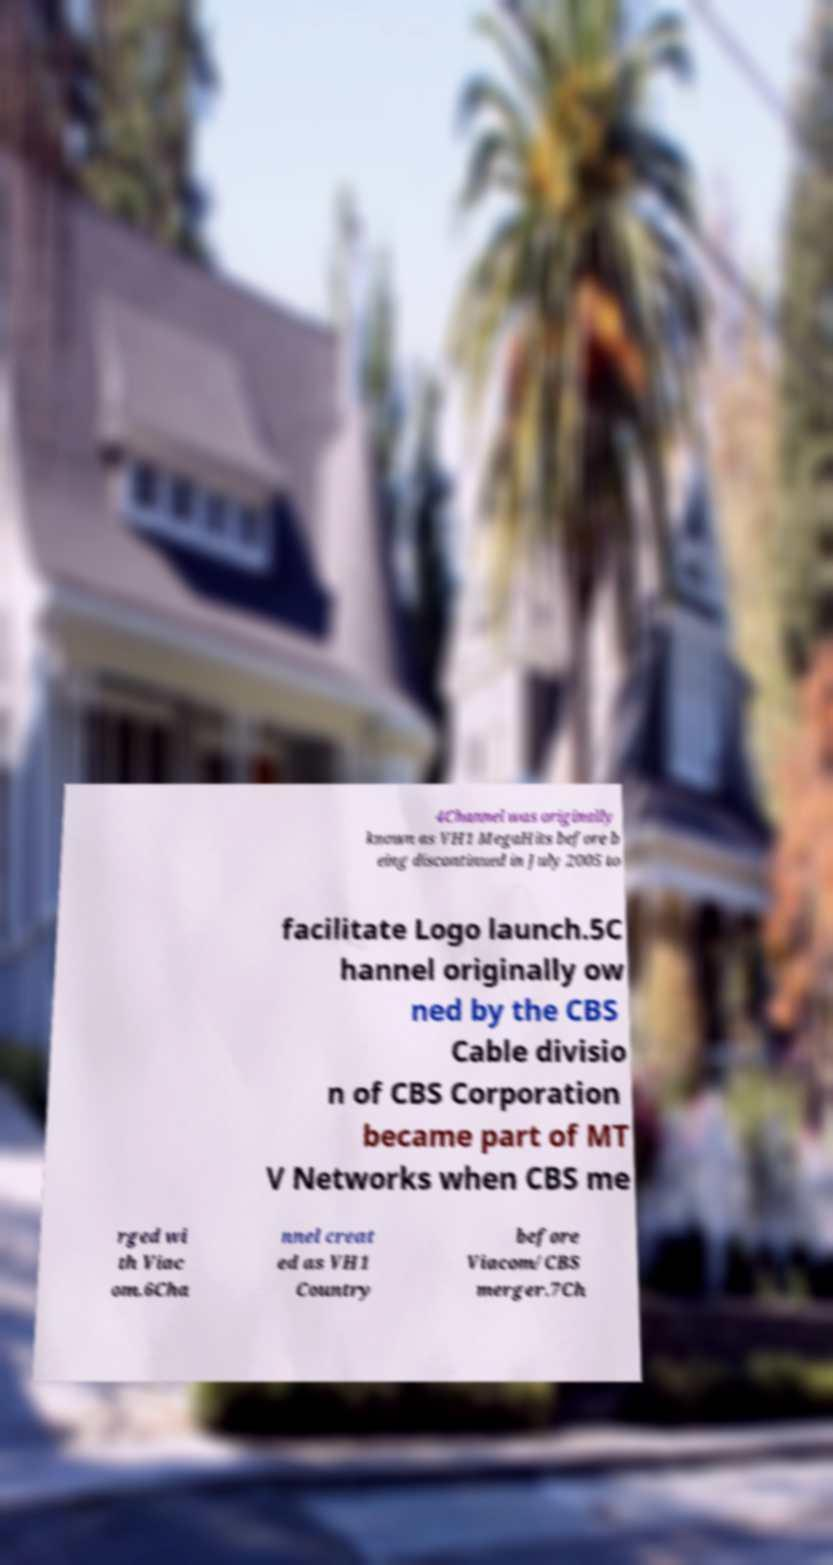Can you read and provide the text displayed in the image?This photo seems to have some interesting text. Can you extract and type it out for me? 4Channel was originally known as VH1 MegaHits before b eing discontinued in July 2005 to facilitate Logo launch.5C hannel originally ow ned by the CBS Cable divisio n of CBS Corporation became part of MT V Networks when CBS me rged wi th Viac om.6Cha nnel creat ed as VH1 Country before Viacom/CBS merger.7Ch 